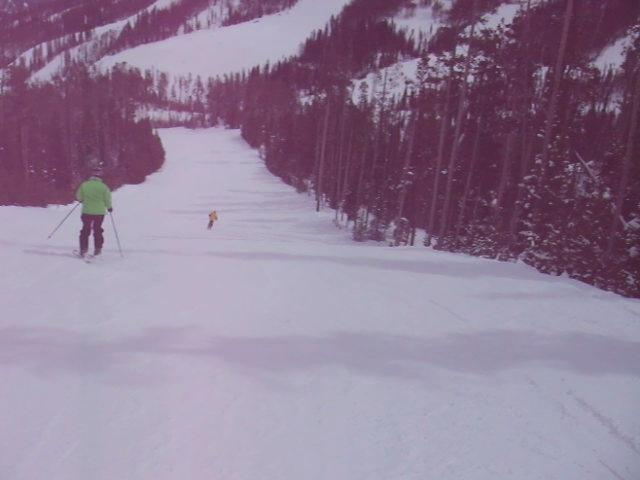What sport would this be if gates were added? slalom 